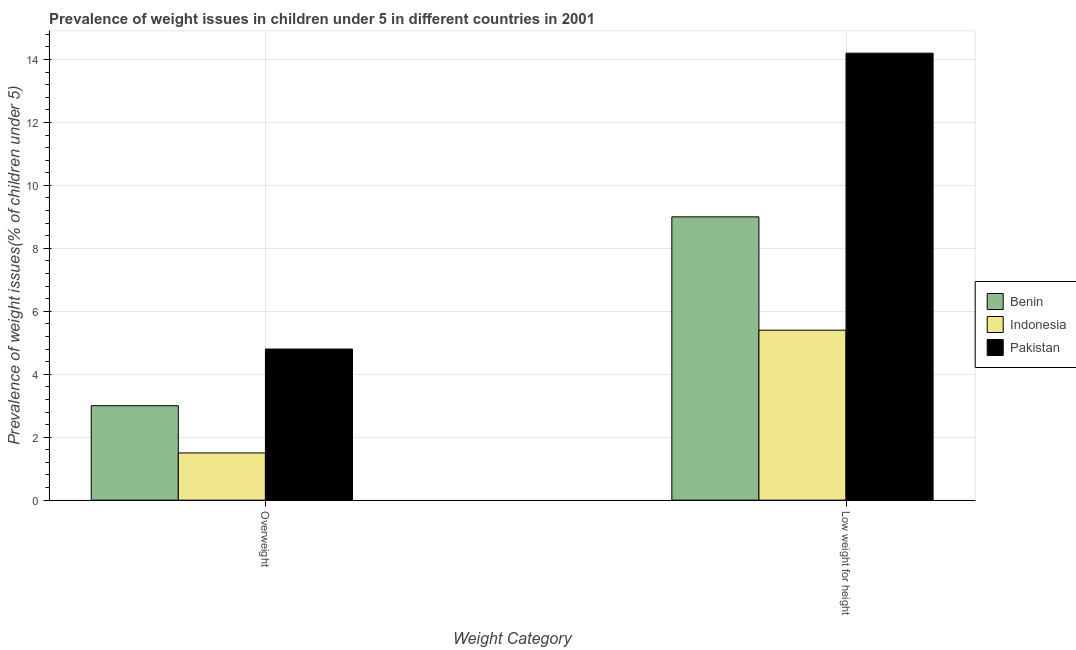How many different coloured bars are there?
Keep it short and to the point. 3. How many groups of bars are there?
Ensure brevity in your answer.  2. How many bars are there on the 2nd tick from the left?
Offer a very short reply. 3. What is the label of the 2nd group of bars from the left?
Make the answer very short. Low weight for height. Across all countries, what is the maximum percentage of underweight children?
Provide a short and direct response. 14.2. Across all countries, what is the minimum percentage of underweight children?
Your answer should be very brief. 5.4. In which country was the percentage of underweight children minimum?
Your answer should be very brief. Indonesia. What is the total percentage of underweight children in the graph?
Ensure brevity in your answer.  28.6. What is the difference between the percentage of overweight children in Indonesia and the percentage of underweight children in Benin?
Provide a succinct answer. -7.5. What is the average percentage of overweight children per country?
Provide a succinct answer. 3.1. What is the difference between the percentage of underweight children and percentage of overweight children in Pakistan?
Your answer should be compact. 9.4. What is the ratio of the percentage of overweight children in Pakistan to that in Indonesia?
Ensure brevity in your answer.  3.2. Is the percentage of overweight children in Pakistan less than that in Benin?
Your answer should be compact. No. In how many countries, is the percentage of underweight children greater than the average percentage of underweight children taken over all countries?
Provide a short and direct response. 1. What does the 1st bar from the left in Overweight represents?
Provide a succinct answer. Benin. What does the 1st bar from the right in Low weight for height represents?
Provide a short and direct response. Pakistan. How many bars are there?
Make the answer very short. 6. Are all the bars in the graph horizontal?
Your response must be concise. No. How many countries are there in the graph?
Give a very brief answer. 3. What is the difference between two consecutive major ticks on the Y-axis?
Provide a succinct answer. 2. Does the graph contain grids?
Your answer should be very brief. Yes. How are the legend labels stacked?
Your response must be concise. Vertical. What is the title of the graph?
Ensure brevity in your answer.  Prevalence of weight issues in children under 5 in different countries in 2001. Does "Lithuania" appear as one of the legend labels in the graph?
Give a very brief answer. No. What is the label or title of the X-axis?
Make the answer very short. Weight Category. What is the label or title of the Y-axis?
Make the answer very short. Prevalence of weight issues(% of children under 5). What is the Prevalence of weight issues(% of children under 5) of Benin in Overweight?
Make the answer very short. 3. What is the Prevalence of weight issues(% of children under 5) of Indonesia in Overweight?
Offer a very short reply. 1.5. What is the Prevalence of weight issues(% of children under 5) in Pakistan in Overweight?
Offer a terse response. 4.8. What is the Prevalence of weight issues(% of children under 5) of Indonesia in Low weight for height?
Provide a succinct answer. 5.4. What is the Prevalence of weight issues(% of children under 5) of Pakistan in Low weight for height?
Provide a succinct answer. 14.2. Across all Weight Category, what is the maximum Prevalence of weight issues(% of children under 5) in Indonesia?
Offer a terse response. 5.4. Across all Weight Category, what is the maximum Prevalence of weight issues(% of children under 5) in Pakistan?
Give a very brief answer. 14.2. Across all Weight Category, what is the minimum Prevalence of weight issues(% of children under 5) in Pakistan?
Your answer should be very brief. 4.8. What is the total Prevalence of weight issues(% of children under 5) of Pakistan in the graph?
Your answer should be compact. 19. What is the difference between the Prevalence of weight issues(% of children under 5) of Benin in Overweight and that in Low weight for height?
Your response must be concise. -6. What is the difference between the Prevalence of weight issues(% of children under 5) of Pakistan in Overweight and that in Low weight for height?
Offer a terse response. -9.4. What is the difference between the Prevalence of weight issues(% of children under 5) in Benin in Overweight and the Prevalence of weight issues(% of children under 5) in Indonesia in Low weight for height?
Offer a very short reply. -2.4. What is the difference between the Prevalence of weight issues(% of children under 5) in Indonesia in Overweight and the Prevalence of weight issues(% of children under 5) in Pakistan in Low weight for height?
Your answer should be very brief. -12.7. What is the average Prevalence of weight issues(% of children under 5) of Indonesia per Weight Category?
Keep it short and to the point. 3.45. What is the average Prevalence of weight issues(% of children under 5) of Pakistan per Weight Category?
Keep it short and to the point. 9.5. What is the difference between the Prevalence of weight issues(% of children under 5) of Benin and Prevalence of weight issues(% of children under 5) of Pakistan in Overweight?
Give a very brief answer. -1.8. What is the difference between the Prevalence of weight issues(% of children under 5) of Benin and Prevalence of weight issues(% of children under 5) of Pakistan in Low weight for height?
Offer a very short reply. -5.2. What is the difference between the Prevalence of weight issues(% of children under 5) in Indonesia and Prevalence of weight issues(% of children under 5) in Pakistan in Low weight for height?
Offer a very short reply. -8.8. What is the ratio of the Prevalence of weight issues(% of children under 5) of Benin in Overweight to that in Low weight for height?
Offer a very short reply. 0.33. What is the ratio of the Prevalence of weight issues(% of children under 5) in Indonesia in Overweight to that in Low weight for height?
Your answer should be very brief. 0.28. What is the ratio of the Prevalence of weight issues(% of children under 5) in Pakistan in Overweight to that in Low weight for height?
Offer a terse response. 0.34. What is the difference between the highest and the second highest Prevalence of weight issues(% of children under 5) in Indonesia?
Your answer should be compact. 3.9. What is the difference between the highest and the lowest Prevalence of weight issues(% of children under 5) in Benin?
Your answer should be compact. 6. What is the difference between the highest and the lowest Prevalence of weight issues(% of children under 5) in Indonesia?
Provide a short and direct response. 3.9. 